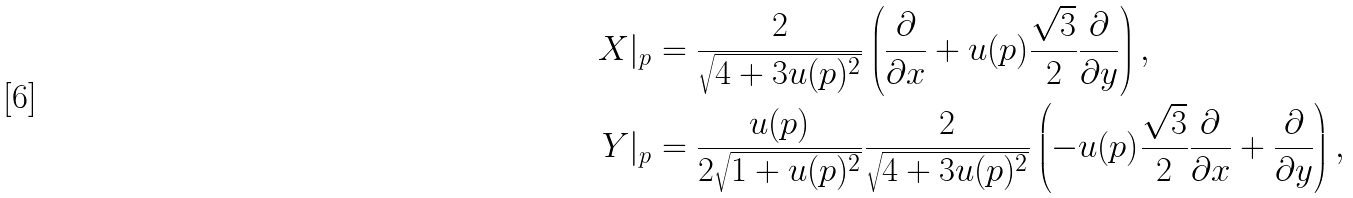Convert formula to latex. <formula><loc_0><loc_0><loc_500><loc_500>X | _ { p } & = \frac { 2 } { \sqrt { 4 + 3 { u } ( p ) ^ { 2 } } } \left ( \frac { \partial } { \partial x } + { u } ( p ) \frac { \sqrt { 3 } } { 2 } \frac { \partial } { \partial y } \right ) , \\ Y | _ { p } & = \frac { { u } ( p ) } { 2 \sqrt { 1 + { u } ( p ) ^ { 2 } } } \frac { 2 } { \sqrt { 4 + 3 { u } ( p ) ^ { 2 } } } \left ( - { u } ( p ) \frac { \sqrt { 3 } } { 2 } \frac { \partial } { \partial x } + \frac { \partial } { \partial y } \right ) ,</formula> 